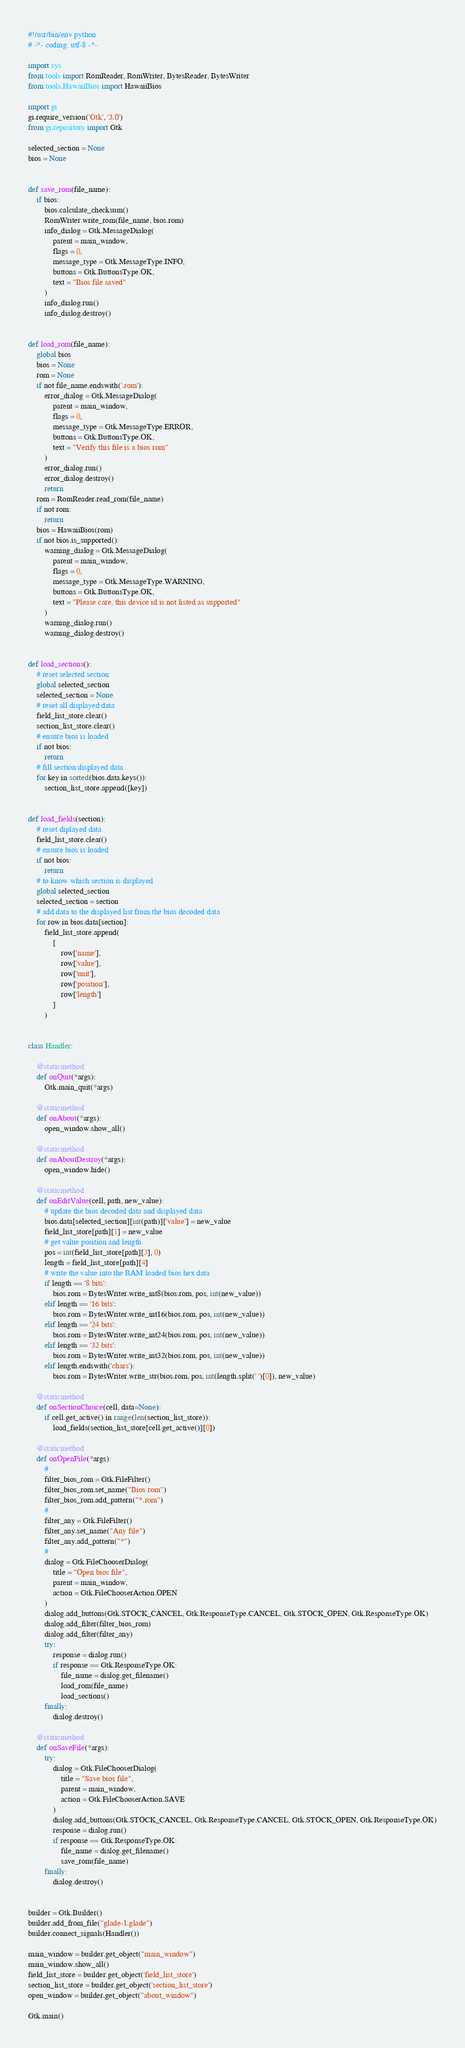Convert code to text. <code><loc_0><loc_0><loc_500><loc_500><_Python_>#!/usr/bin/env python
# -*- coding: utf-8 -*-

import sys
from tools import RomReader, RomWriter, BytesReader, BytesWriter
from tools.HawaiiBios import HawaiiBios

import gi
gi.require_version('Gtk', '3.0')
from gi.repository import Gtk

selected_section = None
bios = None


def save_rom(file_name):
    if bios:
        bios.calculate_checksum()
        RomWriter.write_rom(file_name, bios.rom)
        info_dialog = Gtk.MessageDialog(
            parent = main_window,
            flags = 0,
            message_type = Gtk.MessageType.INFO,
            buttons = Gtk.ButtonsType.OK,
            text = "Bios file saved"
        )
        info_dialog.run()
        info_dialog.destroy()


def load_rom(file_name):
    global bios
    bios = None
    rom = None
    if not file_name.endswith('.rom'):
        error_dialog = Gtk.MessageDialog(
            parent = main_window,
            flags = 0,
            message_type = Gtk.MessageType.ERROR,
            buttons = Gtk.ButtonsType.OK,
            text = "Verify this file is a bios rom"
        )
        error_dialog.run()
        error_dialog.destroy()
        return
    rom = RomReader.read_rom(file_name)
    if not rom:
        return
    bios = HawaiiBios(rom)
    if not bios.is_supported():
        warning_dialog = Gtk.MessageDialog(
            parent = main_window,
            flags = 0,
            message_type = Gtk.MessageType.WARNING,
            buttons = Gtk.ButtonsType.OK,
            text = "Please care, this device id is not listed as supported"
        )
        warning_dialog.run()
        warning_dialog.destroy()


def load_sections():
    # reset selected section
    global selected_section
    selected_section = None
    # reset all displayed data
    field_list_store.clear()
    section_list_store.clear()
    # ensure bios is loaded
    if not bios:
        return
    # fill section displayed data
    for key in sorted(bios.data.keys()):
        section_list_store.append([key])


def load_fields(section):
    # reset diplayed data
    field_list_store.clear()
    # ensure bios is loaded
    if not bios:
        return
    # to know which section is displayed
    global selected_section
    selected_section = section
    # add data to the displayed list from the bios decoded data
    for row in bios.data[section]:
        field_list_store.append(
            [
                row['name'],
                row['value'],
                row['unit'],
                row['position'],
                row['length']
            ]
        )


class Handler:

    @staticmethod
    def onQuit(*args):
        Gtk.main_quit(*args)

    @staticmethod
    def onAbout(*args):
        open_window.show_all()

    @staticmethod
    def onAboutDestroy(*args):
        open_window.hide()

    @staticmethod
    def onEditValue(cell, path, new_value):
        # update the bios decoded data and displayed data
        bios.data[selected_section][int(path)]['value'] = new_value
        field_list_store[path][1] = new_value
        # get value position and length
        pos = int(field_list_store[path][3], 0)
        length = field_list_store[path][4]
        # write the value into the RAM loaded bios hex data
        if length == '8 bits':
            bios.rom = BytesWriter.write_int8(bios.rom, pos, int(new_value))
        elif length == '16 bits':
            bios.rom = BytesWriter.write_int16(bios.rom, pos, int(new_value))
        elif length == '24 bits':
            bios.rom = BytesWriter.write_int24(bios.rom, pos, int(new_value))
        elif length == '32 bits':
            bios.rom = BytesWriter.write_int32(bios.rom, pos, int(new_value))
        elif length.endswith('chars'):
            bios.rom = BytesWriter.write_str(bios.rom, pos, int(length.split(' ')[0]), new_value)

    @staticmethod
    def onSectionChoice(cell, data=None):
        if cell.get_active() in range(len(section_list_store)):
            load_fields(section_list_store[cell.get_active()][0])

    @staticmethod
    def onOpenFile(*args):
        #
        filter_bios_rom = Gtk.FileFilter()
        filter_bios_rom.set_name("Bios rom")
        filter_bios_rom.add_pattern("*.rom")
        #
        filter_any = Gtk.FileFilter()
        filter_any.set_name("Any file")
        filter_any.add_pattern("*")
        #
        dialog = Gtk.FileChooserDialog(
            title = "Open bios file",
            parent = main_window,
            action = Gtk.FileChooserAction.OPEN
        )
        dialog.add_buttons(Gtk.STOCK_CANCEL, Gtk.ResponseType.CANCEL, Gtk.STOCK_OPEN, Gtk.ResponseType.OK)
        dialog.add_filter(filter_bios_rom)
        dialog.add_filter(filter_any)
        try:
            response = dialog.run()
            if response == Gtk.ResponseType.OK:
                file_name = dialog.get_filename()
                load_rom(file_name)
                load_sections()
        finally:
            dialog.destroy()

    @staticmethod
    def onSaveFile(*args):
        try:
            dialog = Gtk.FileChooserDialog(
                title = "Save bios file",
                parent = main_window,
                action = Gtk.FileChooserAction.SAVE
            )
            dialog.add_buttons(Gtk.STOCK_CANCEL, Gtk.ResponseType.CANCEL, Gtk.STOCK_OPEN, Gtk.ResponseType.OK)
            response = dialog.run()
            if response == Gtk.ResponseType.OK:
                file_name = dialog.get_filename()
                save_rom(file_name)
        finally:
            dialog.destroy()


builder = Gtk.Builder()
builder.add_from_file("glade-1.glade")
builder.connect_signals(Handler())

main_window = builder.get_object("main_window")
main_window.show_all()
field_list_store = builder.get_object('field_list_store')
section_list_store = builder.get_object('section_list_store')
open_window = builder.get_object("about_window")

Gtk.main()
</code> 